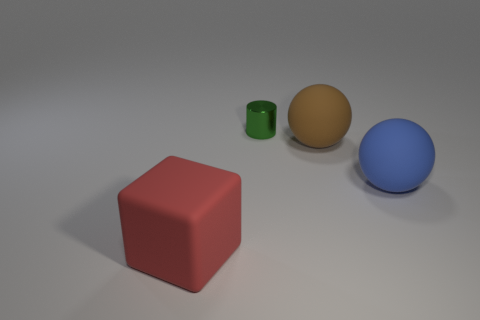There is a sphere that is left of the blue ball; what is its material?
Offer a terse response. Rubber. Are there any brown rubber things that have the same shape as the blue thing?
Offer a very short reply. Yes. What number of other things are there of the same shape as the large red matte object?
Ensure brevity in your answer.  0. There is a blue object; is its shape the same as the large rubber object that is behind the large blue matte object?
Offer a terse response. Yes. Is there anything else that is made of the same material as the tiny object?
Your response must be concise. No. How many big objects are either gray metallic objects or spheres?
Your answer should be compact. 2. Is the number of red things in front of the tiny green metal thing less than the number of large blue things that are right of the large red thing?
Provide a short and direct response. No. How many things are either tiny yellow matte spheres or big rubber things?
Your answer should be compact. 3. How many big red things are on the right side of the green shiny object?
Provide a short and direct response. 0. Does the small thing have the same color as the large block?
Give a very brief answer. No. 